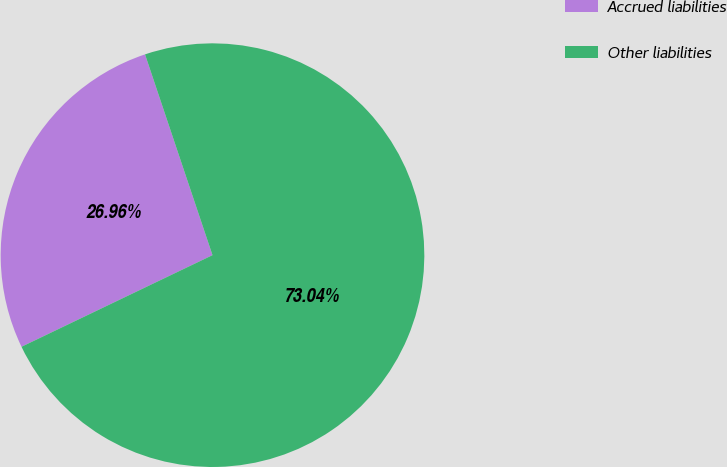Convert chart to OTSL. <chart><loc_0><loc_0><loc_500><loc_500><pie_chart><fcel>Accrued liabilities<fcel>Other liabilities<nl><fcel>26.96%<fcel>73.04%<nl></chart> 